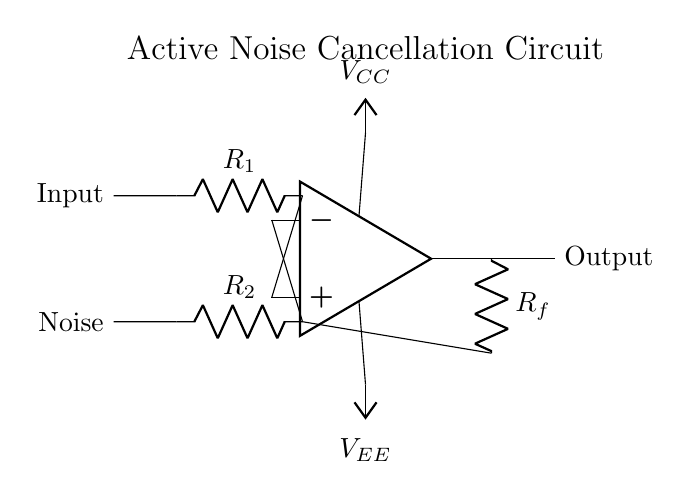What is the type of circuit shown? The circuit is an operational amplifier circuit designed for active noise cancellation, as indicated by its structure and the label at the top.
Answer: Operational amplifier What are the two main inputs to the op-amp? The circuit shows an input and a noise signal connected to the op-amp's non-inverting and inverting terminals, respectively.
Answer: Input and Noise What components are used for feedback in this circuit? The feedback loop consists of a resistor labeled Rf, which connects the output of the op-amp back to its inverting terminal, creating the necessary feedback for the circuit’s operation.
Answer: Rf What is the role of resistor R1? Resistor R1 is connected to the non-inverting terminal of the op-amp and is part of the signal input path; it helps set the gain of the circuit alongside Rf.
Answer: Signal gain How does the op-amp amplify the noise signal? The op-amp amplifies the difference between its two input signals (the input and noise) based on the resistors' configuration, leading to active noise cancellation. This is a fundamental principle of operational amplifier usage.
Answer: By amplifying the difference input What are the power supply voltages used in this circuit? The op-amp requires two power supply voltages, denoted as Vcc and Vee, which provide the necessary power for operation. The circuit shows them connected to the op-amp terminals.
Answer: Vcc and Vee 